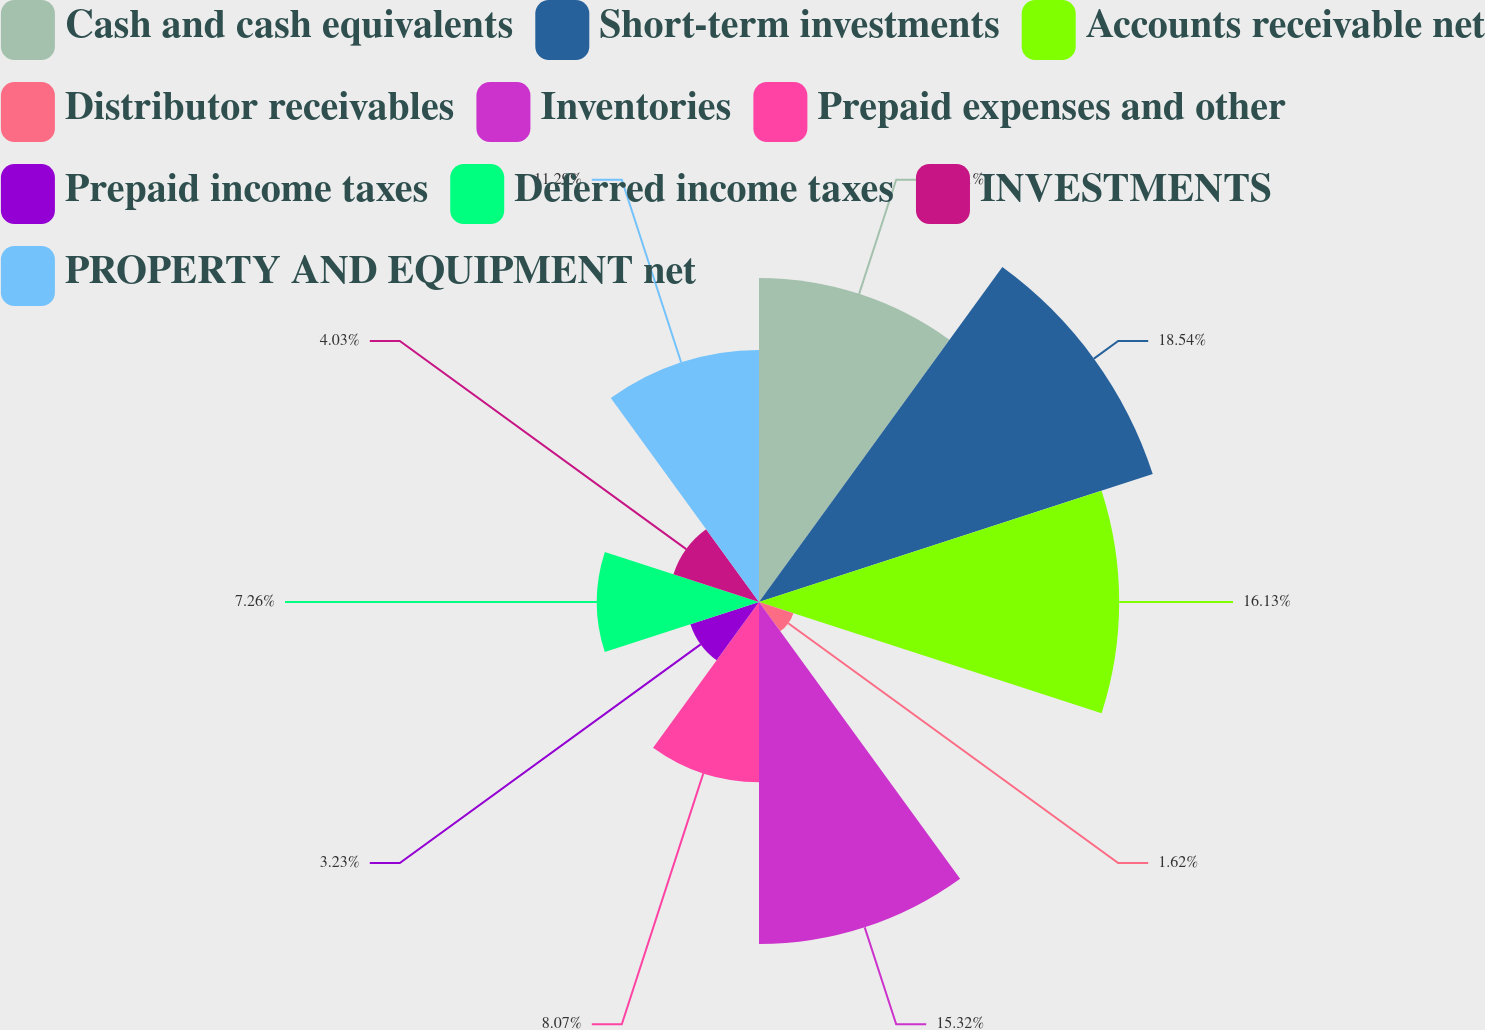<chart> <loc_0><loc_0><loc_500><loc_500><pie_chart><fcel>Cash and cash equivalents<fcel>Short-term investments<fcel>Accounts receivable net<fcel>Distributor receivables<fcel>Inventories<fcel>Prepaid expenses and other<fcel>Prepaid income taxes<fcel>Deferred income taxes<fcel>INVESTMENTS<fcel>PROPERTY AND EQUIPMENT net<nl><fcel>14.51%<fcel>18.54%<fcel>16.13%<fcel>1.62%<fcel>15.32%<fcel>8.07%<fcel>3.23%<fcel>7.26%<fcel>4.03%<fcel>11.29%<nl></chart> 